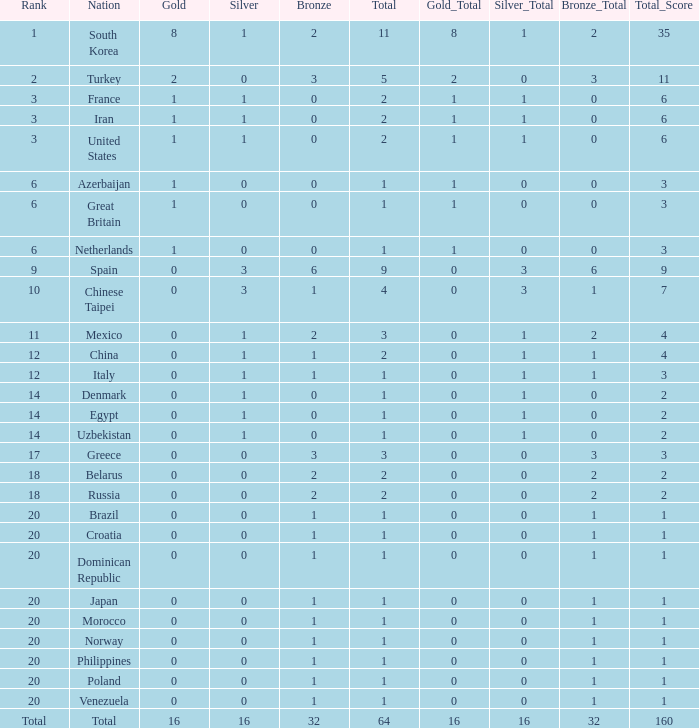How many total silvers does Russia have? 1.0. 